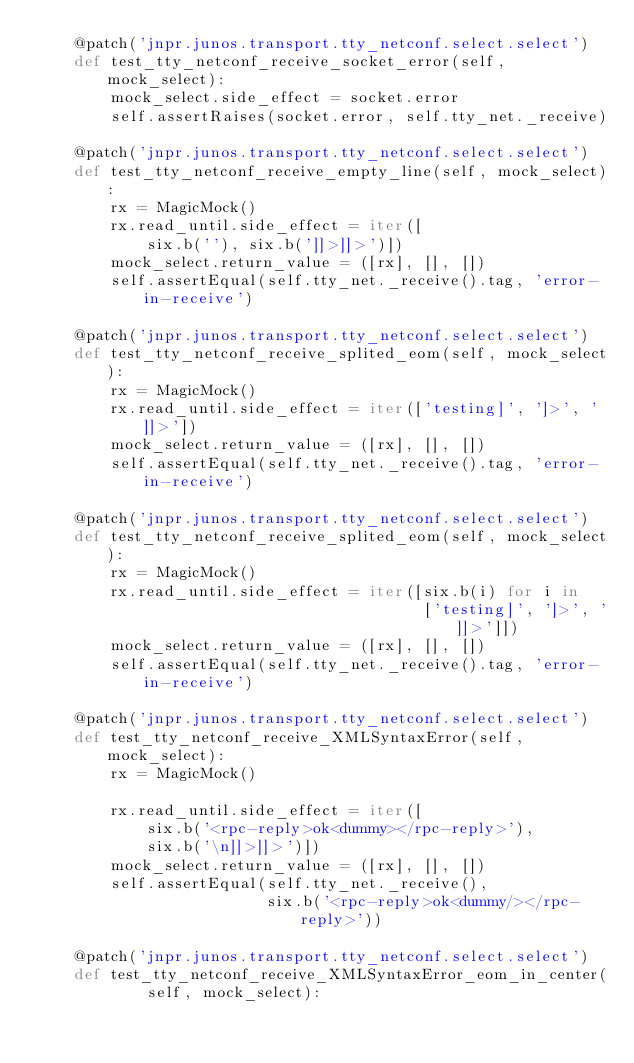Convert code to text. <code><loc_0><loc_0><loc_500><loc_500><_Python_>    @patch('jnpr.junos.transport.tty_netconf.select.select')
    def test_tty_netconf_receive_socket_error(self, mock_select):
        mock_select.side_effect = socket.error
        self.assertRaises(socket.error, self.tty_net._receive)

    @patch('jnpr.junos.transport.tty_netconf.select.select')
    def test_tty_netconf_receive_empty_line(self, mock_select):
        rx = MagicMock()
        rx.read_until.side_effect = iter([
            six.b(''), six.b(']]>]]>')])
        mock_select.return_value = ([rx], [], [])
        self.assertEqual(self.tty_net._receive().tag, 'error-in-receive')

    @patch('jnpr.junos.transport.tty_netconf.select.select')
    def test_tty_netconf_receive_splited_eom(self, mock_select):
        rx = MagicMock()
        rx.read_until.side_effect = iter(['testing]', ']>', ']]>'])
        mock_select.return_value = ([rx], [], [])
        self.assertEqual(self.tty_net._receive().tag, 'error-in-receive')

    @patch('jnpr.junos.transport.tty_netconf.select.select')
    def test_tty_netconf_receive_splited_eom(self, mock_select):
        rx = MagicMock()
        rx.read_until.side_effect = iter([six.b(i) for i in
                                          ['testing]', ']>', ']]>']])
        mock_select.return_value = ([rx], [], [])
        self.assertEqual(self.tty_net._receive().tag, 'error-in-receive')

    @patch('jnpr.junos.transport.tty_netconf.select.select')
    def test_tty_netconf_receive_XMLSyntaxError(self, mock_select):
        rx = MagicMock()

        rx.read_until.side_effect = iter([
            six.b('<rpc-reply>ok<dummy></rpc-reply>'),
            six.b('\n]]>]]>')])
        mock_select.return_value = ([rx], [], [])
        self.assertEqual(self.tty_net._receive(),
                         six.b('<rpc-reply>ok<dummy/></rpc-reply>'))

    @patch('jnpr.junos.transport.tty_netconf.select.select')
    def test_tty_netconf_receive_XMLSyntaxError_eom_in_center(
            self, mock_select):</code> 